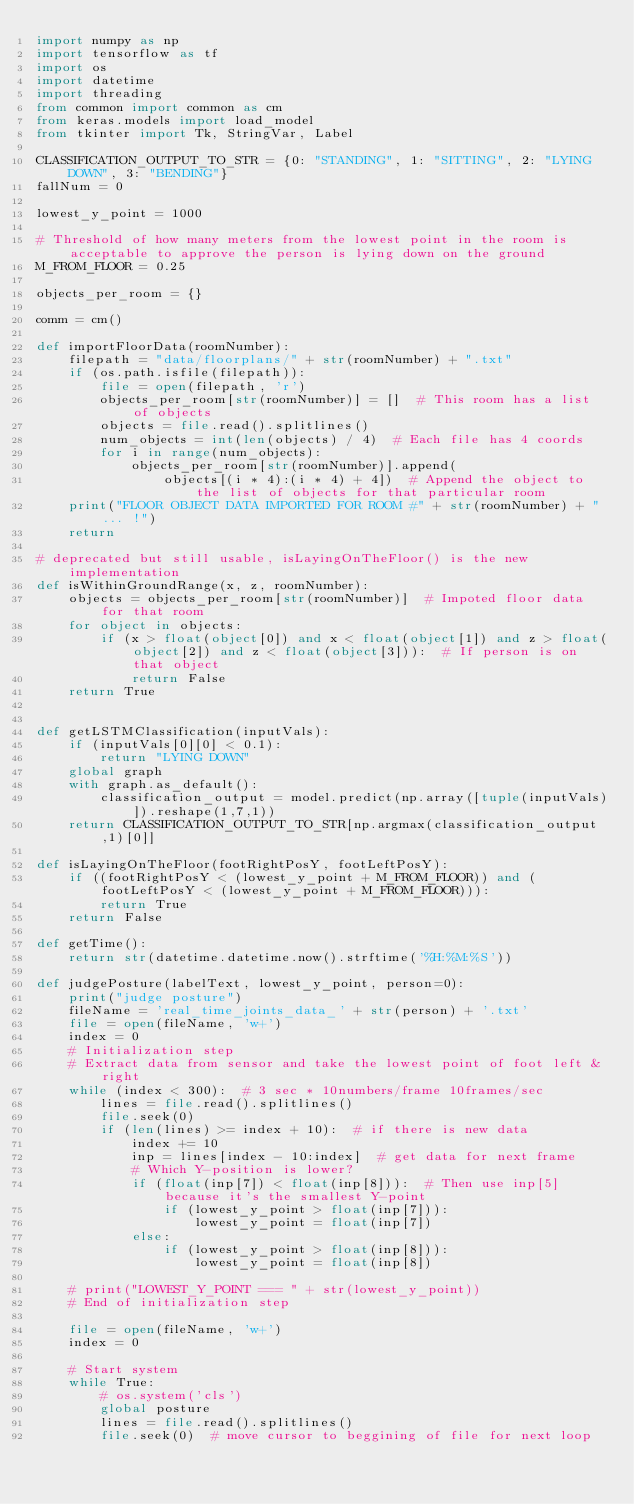<code> <loc_0><loc_0><loc_500><loc_500><_Python_>import numpy as np
import tensorflow as tf
import os
import datetime
import threading
from common import common as cm
from keras.models import load_model
from tkinter import Tk, StringVar, Label
    
CLASSIFICATION_OUTPUT_TO_STR = {0: "STANDING", 1: "SITTING", 2: "LYING DOWN", 3: "BENDING"}
fallNum = 0

lowest_y_point = 1000

# Threshold of how many meters from the lowest point in the room is acceptable to approve the person is lying down on the ground
M_FROM_FLOOR = 0.25

objects_per_room = {}   

comm = cm()

def importFloorData(roomNumber):
    filepath = "data/floorplans/" + str(roomNumber) + ".txt"
    if (os.path.isfile(filepath)):
        file = open(filepath, 'r')
        objects_per_room[str(roomNumber)] = []  # This room has a list of objects
        objects = file.read().splitlines()
        num_objects = int(len(objects) / 4)  # Each file has 4 coords
        for i in range(num_objects):
            objects_per_room[str(roomNumber)].append(
                objects[(i * 4):(i * 4) + 4])  # Append the object to the list of objects for that particular room
    print("FLOOR OBJECT DATA IMPORTED FOR ROOM #" + str(roomNumber) + "... !")
    return

# deprecated but still usable, isLayingOnTheFloor() is the new implementation
def isWithinGroundRange(x, z, roomNumber):
    objects = objects_per_room[str(roomNumber)]  # Impoted floor data for that room
    for object in objects:
        if (x > float(object[0]) and x < float(object[1]) and z > float(object[2]) and z < float(object[3])):  # If person is on that object
            return False
    return True


def getLSTMClassification(inputVals):
    if (inputVals[0][0] < 0.1):
        return "LYING DOWN"
    global graph
    with graph.as_default():
        classification_output = model.predict(np.array([tuple(inputVals)]).reshape(1,7,1))
    return CLASSIFICATION_OUTPUT_TO_STR[np.argmax(classification_output,1)[0]]

def isLayingOnTheFloor(footRightPosY, footLeftPosY):
    if ((footRightPosY < (lowest_y_point + M_FROM_FLOOR)) and (footLeftPosY < (lowest_y_point + M_FROM_FLOOR))):
        return True
    return False

def getTime():
    return str(datetime.datetime.now().strftime('%H:%M:%S'))

def judgePosture(labelText, lowest_y_point, person=0):
    print("judge posture")
    fileName = 'real_time_joints_data_' + str(person) + '.txt'
    file = open(fileName, 'w+')
    index = 0
    # Initialization step
    # Extract data from sensor and take the lowest point of foot left & right
    while (index < 300):  # 3 sec * 10numbers/frame 10frames/sec
        lines = file.read().splitlines()
        file.seek(0)
        if (len(lines) >= index + 10):  # if there is new data
            index += 10
            inp = lines[index - 10:index]  # get data for next frame
            # Which Y-position is lower?
            if (float(inp[7]) < float(inp[8])):  # Then use inp[5] because it's the smallest Y-point
                if (lowest_y_point > float(inp[7])):
                    lowest_y_point = float(inp[7])
            else:
                if (lowest_y_point > float(inp[8])):
                    lowest_y_point = float(inp[8])

    # print("LOWEST_Y_POINT === " + str(lowest_y_point))
    # End of initialization step

    file = open(fileName, 'w+')
    index = 0

    # Start system
    while True:
        # os.system('cls')
        global posture
        lines = file.read().splitlines()
        file.seek(0)  # move cursor to beggining of file for next loop</code> 